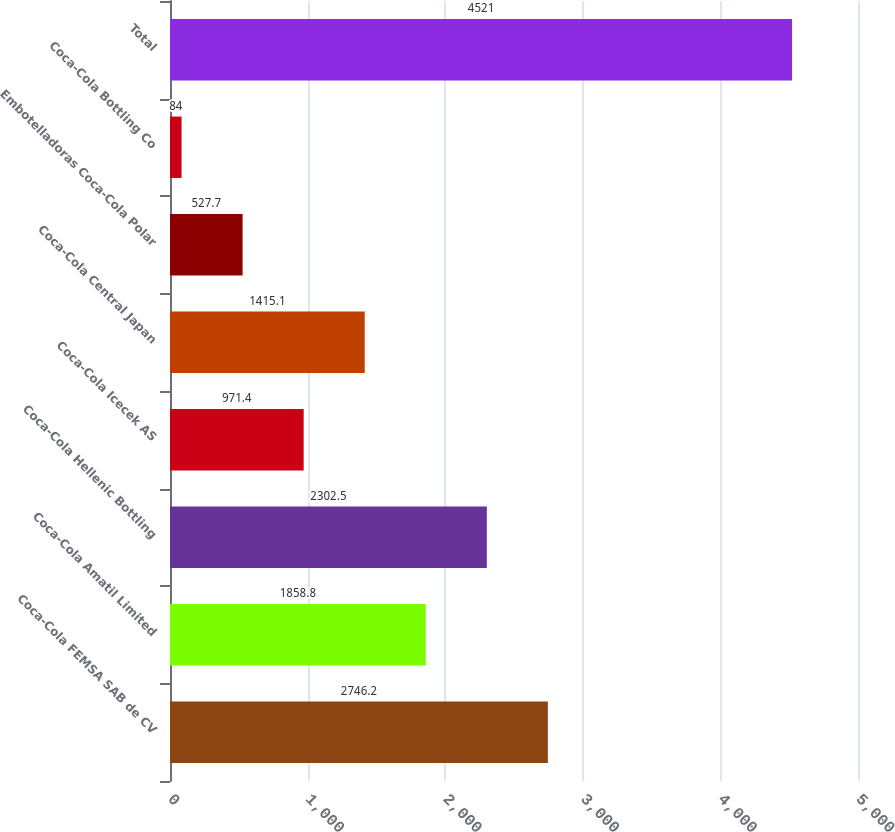Convert chart to OTSL. <chart><loc_0><loc_0><loc_500><loc_500><bar_chart><fcel>Coca-Cola FEMSA SAB de CV<fcel>Coca-Cola Amatil Limited<fcel>Coca-Cola Hellenic Bottling<fcel>Coca-Cola Icecek AS<fcel>Coca-Cola Central Japan<fcel>Embotelladoras Coca-Cola Polar<fcel>Coca-Cola Bottling Co<fcel>Total<nl><fcel>2746.2<fcel>1858.8<fcel>2302.5<fcel>971.4<fcel>1415.1<fcel>527.7<fcel>84<fcel>4521<nl></chart> 